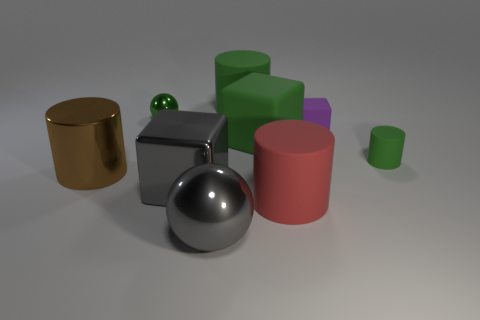What shape is the small green object behind the green matte cylinder on the right side of the green cylinder that is behind the big green matte cube?
Ensure brevity in your answer.  Sphere. There is a tiny green object that is behind the small green rubber object; what is its material?
Provide a short and direct response. Metal. There is a rubber cube that is the same size as the green metal sphere; what color is it?
Keep it short and to the point. Purple. How many other things are there of the same shape as the red object?
Your answer should be very brief. 3. Is the brown shiny object the same size as the purple object?
Give a very brief answer. No. Are there more big green blocks behind the large metal cylinder than big red matte cylinders that are to the left of the large rubber cube?
Give a very brief answer. Yes. What number of other things are there of the same size as the gray metallic block?
Your answer should be compact. 5. There is a large rubber cylinder that is behind the large red matte cylinder; is its color the same as the metallic block?
Offer a very short reply. No. Is the number of metal objects behind the large red object greater than the number of large gray shiny objects?
Keep it short and to the point. Yes. Is there any other thing that is the same color as the large rubber cube?
Ensure brevity in your answer.  Yes. 